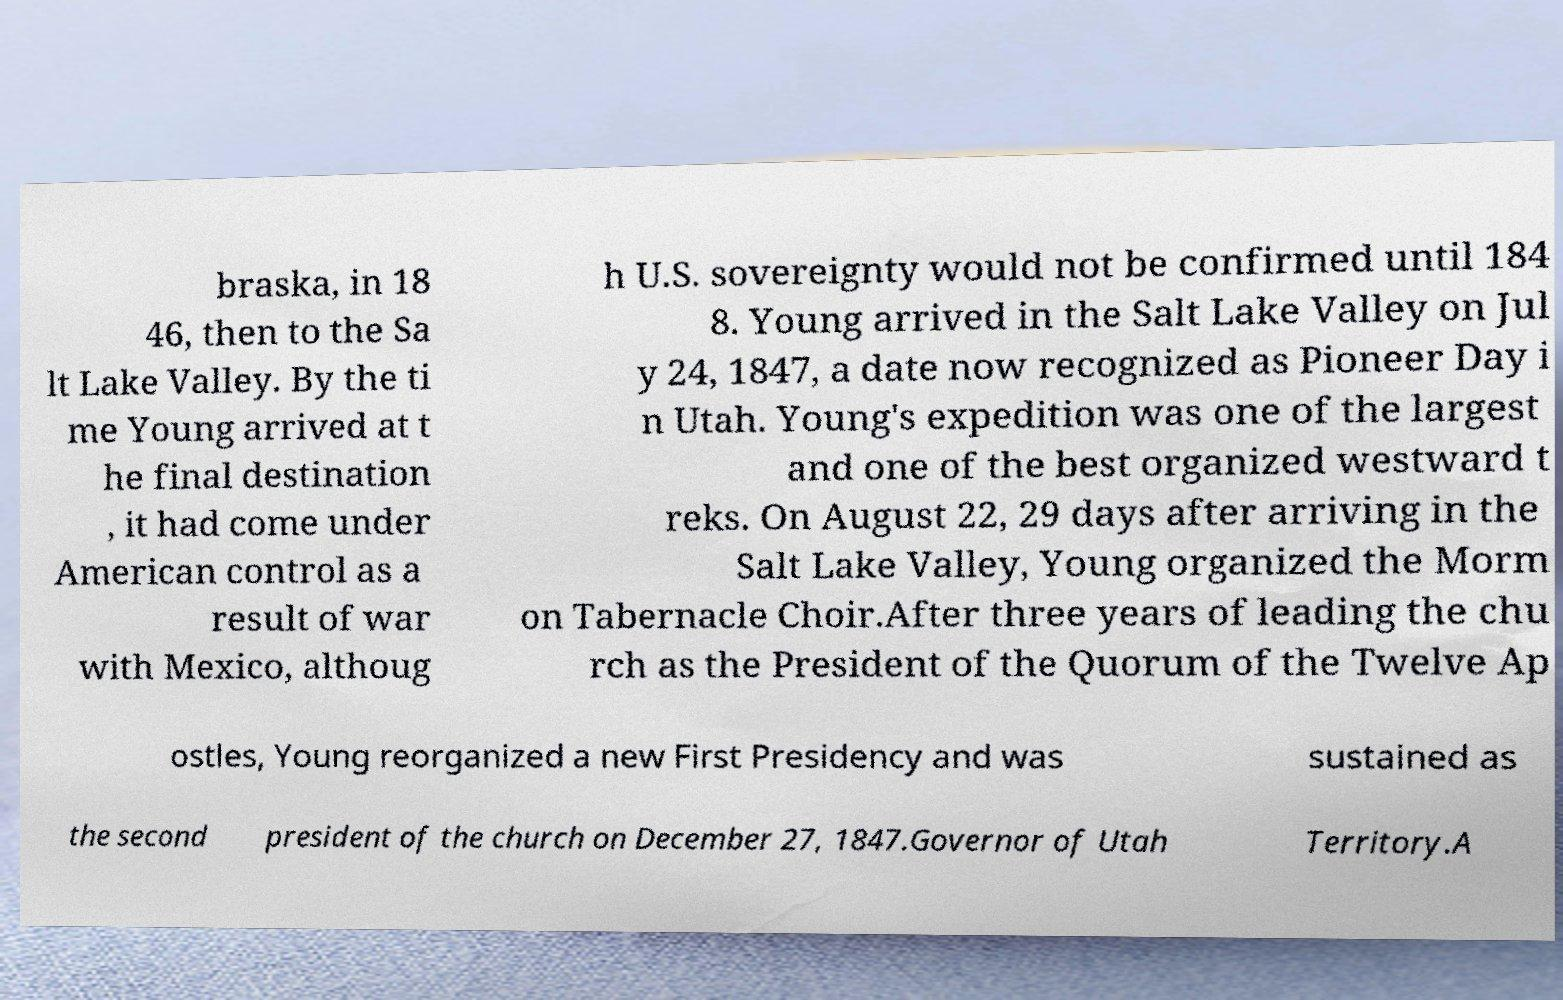Can you accurately transcribe the text from the provided image for me? braska, in 18 46, then to the Sa lt Lake Valley. By the ti me Young arrived at t he final destination , it had come under American control as a result of war with Mexico, althoug h U.S. sovereignty would not be confirmed until 184 8. Young arrived in the Salt Lake Valley on Jul y 24, 1847, a date now recognized as Pioneer Day i n Utah. Young's expedition was one of the largest and one of the best organized westward t reks. On August 22, 29 days after arriving in the Salt Lake Valley, Young organized the Morm on Tabernacle Choir.After three years of leading the chu rch as the President of the Quorum of the Twelve Ap ostles, Young reorganized a new First Presidency and was sustained as the second president of the church on December 27, 1847.Governor of Utah Territory.A 